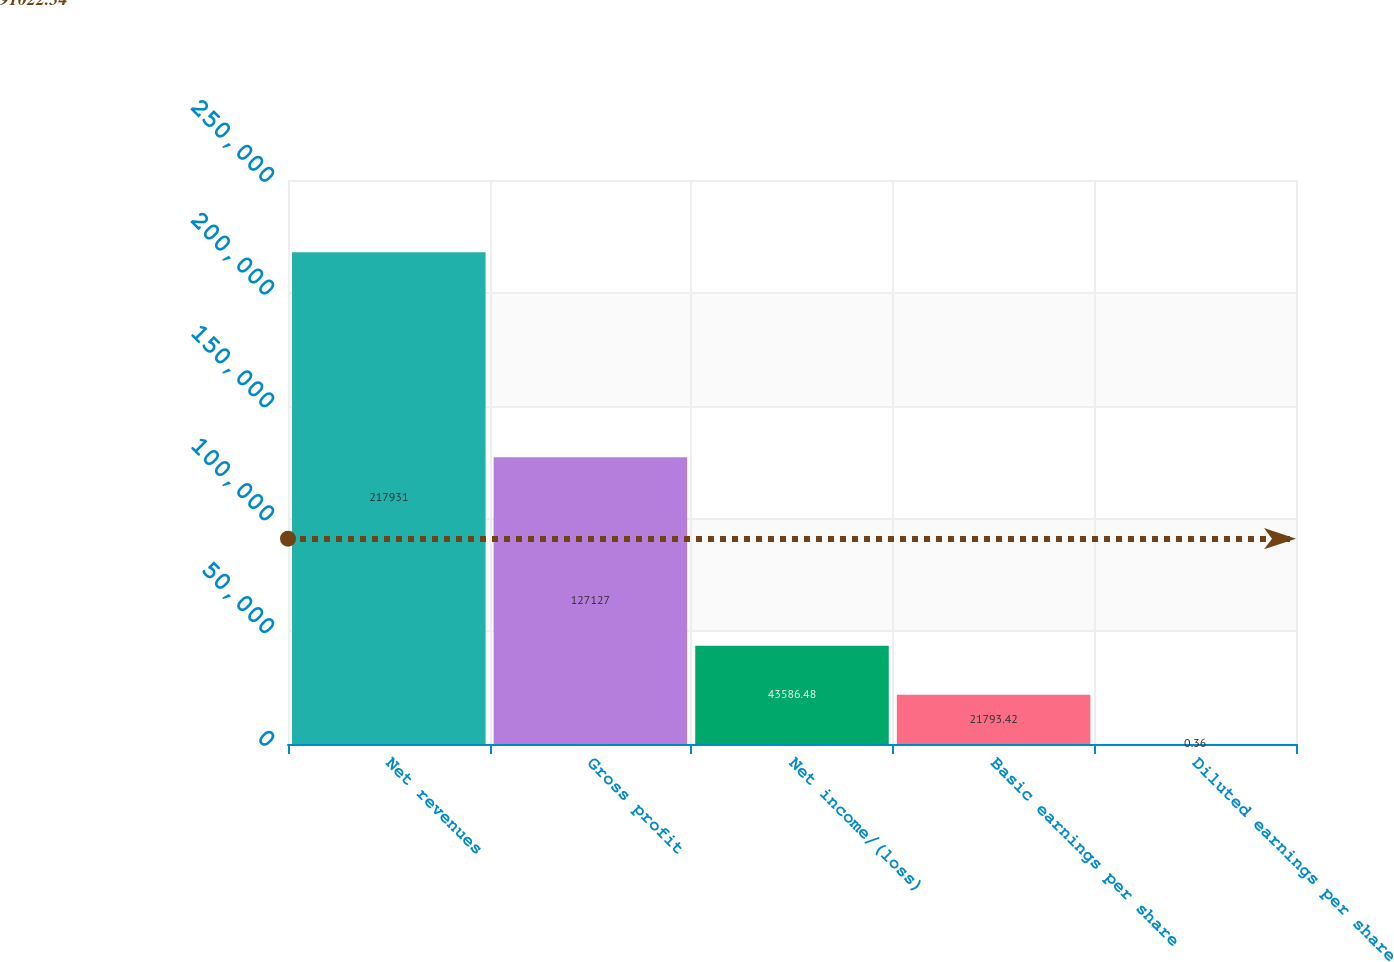Convert chart to OTSL. <chart><loc_0><loc_0><loc_500><loc_500><bar_chart><fcel>Net revenues<fcel>Gross profit<fcel>Net income/(loss)<fcel>Basic earnings per share<fcel>Diluted earnings per share<nl><fcel>217931<fcel>127127<fcel>43586.5<fcel>21793.4<fcel>0.36<nl></chart> 